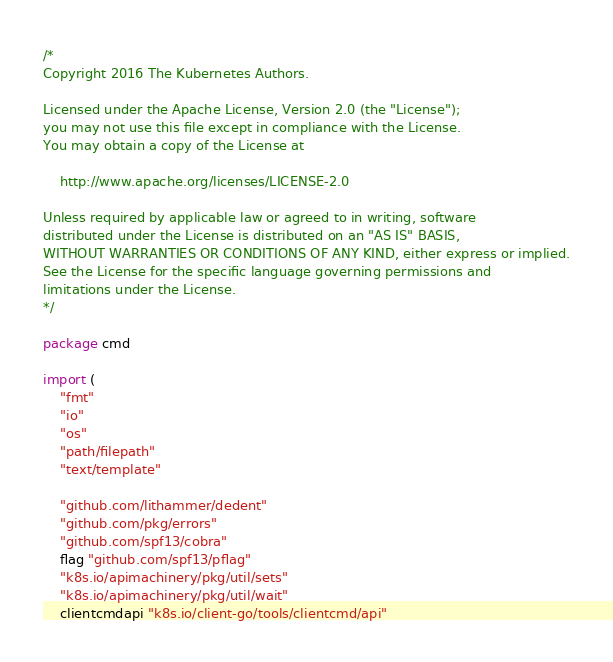Convert code to text. <code><loc_0><loc_0><loc_500><loc_500><_Go_>/*
Copyright 2016 The Kubernetes Authors.

Licensed under the Apache License, Version 2.0 (the "License");
you may not use this file except in compliance with the License.
You may obtain a copy of the License at

    http://www.apache.org/licenses/LICENSE-2.0

Unless required by applicable law or agreed to in writing, software
distributed under the License is distributed on an "AS IS" BASIS,
WITHOUT WARRANTIES OR CONDITIONS OF ANY KIND, either express or implied.
See the License for the specific language governing permissions and
limitations under the License.
*/

package cmd

import (
	"fmt"
	"io"
	"os"
	"path/filepath"
	"text/template"

	"github.com/lithammer/dedent"
	"github.com/pkg/errors"
	"github.com/spf13/cobra"
	flag "github.com/spf13/pflag"
	"k8s.io/apimachinery/pkg/util/sets"
	"k8s.io/apimachinery/pkg/util/wait"
	clientcmdapi "k8s.io/client-go/tools/clientcmd/api"</code> 